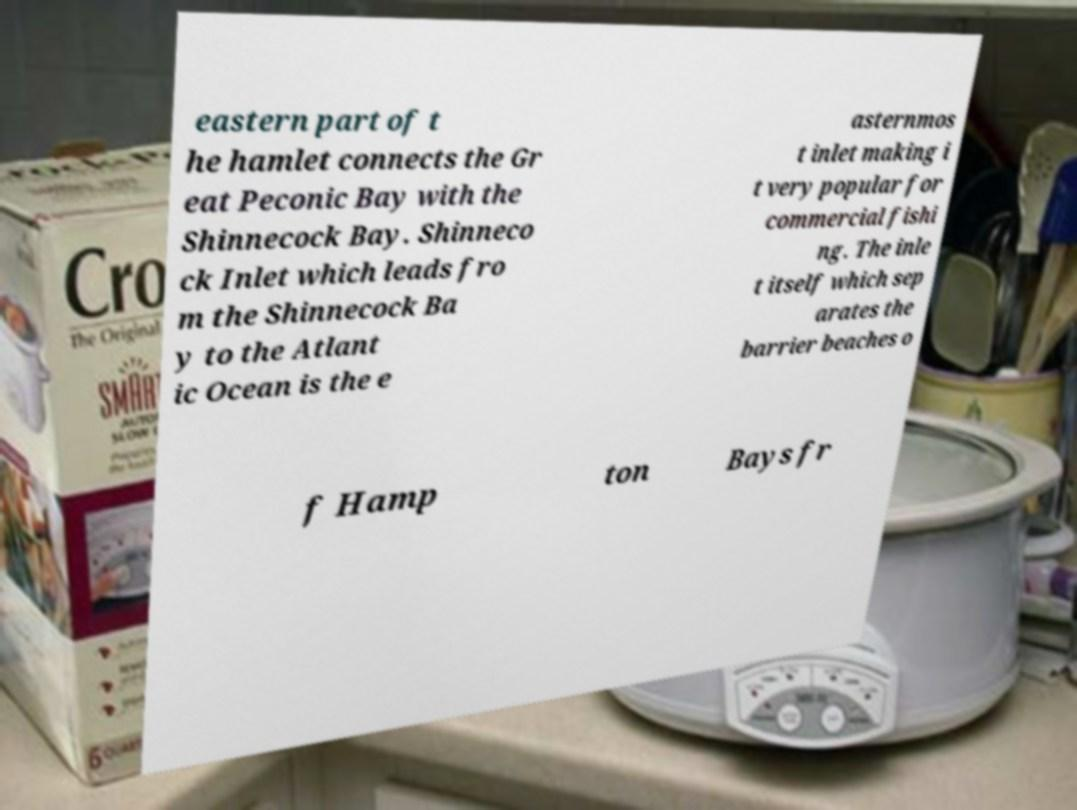Can you read and provide the text displayed in the image?This photo seems to have some interesting text. Can you extract and type it out for me? eastern part of t he hamlet connects the Gr eat Peconic Bay with the Shinnecock Bay. Shinneco ck Inlet which leads fro m the Shinnecock Ba y to the Atlant ic Ocean is the e asternmos t inlet making i t very popular for commercial fishi ng. The inle t itself which sep arates the barrier beaches o f Hamp ton Bays fr 